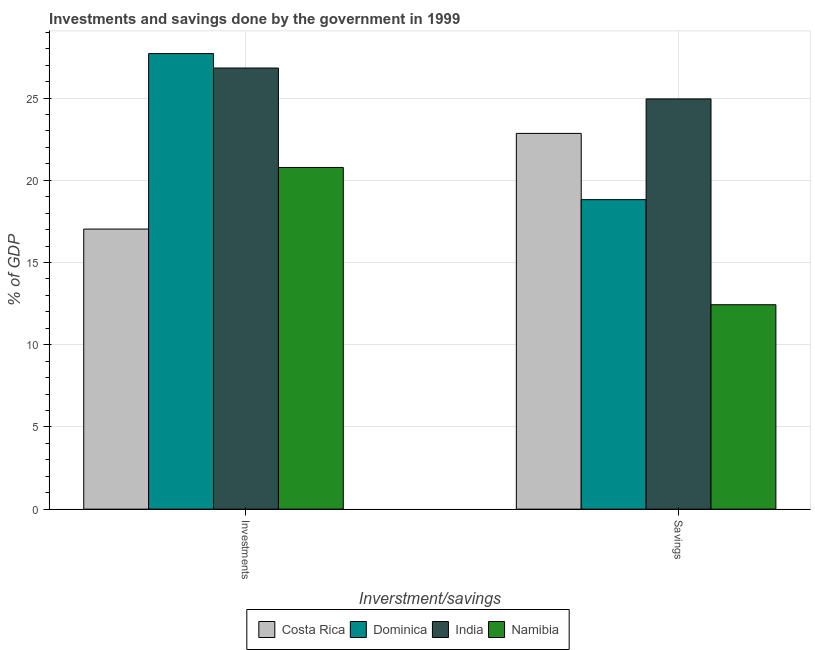How many groups of bars are there?
Provide a succinct answer. 2. Are the number of bars on each tick of the X-axis equal?
Provide a short and direct response. Yes. How many bars are there on the 2nd tick from the left?
Offer a very short reply. 4. How many bars are there on the 2nd tick from the right?
Your answer should be compact. 4. What is the label of the 2nd group of bars from the left?
Offer a terse response. Savings. What is the savings of government in Dominica?
Your answer should be compact. 18.82. Across all countries, what is the maximum investments of government?
Make the answer very short. 27.7. Across all countries, what is the minimum investments of government?
Give a very brief answer. 17.03. In which country was the savings of government maximum?
Give a very brief answer. India. What is the total investments of government in the graph?
Provide a succinct answer. 92.33. What is the difference between the savings of government in Dominica and that in Costa Rica?
Make the answer very short. -4.03. What is the difference between the savings of government in Costa Rica and the investments of government in India?
Your answer should be very brief. -3.97. What is the average investments of government per country?
Your answer should be compact. 23.08. What is the difference between the savings of government and investments of government in Costa Rica?
Ensure brevity in your answer.  5.82. What is the ratio of the investments of government in Namibia to that in Dominica?
Provide a succinct answer. 0.75. What does the 2nd bar from the left in Investments represents?
Your answer should be very brief. Dominica. What does the 4th bar from the right in Investments represents?
Your response must be concise. Costa Rica. How many countries are there in the graph?
Give a very brief answer. 4. What is the difference between two consecutive major ticks on the Y-axis?
Provide a succinct answer. 5. Does the graph contain any zero values?
Ensure brevity in your answer.  No. Does the graph contain grids?
Offer a very short reply. Yes. Where does the legend appear in the graph?
Offer a terse response. Bottom center. How are the legend labels stacked?
Your answer should be very brief. Horizontal. What is the title of the graph?
Provide a succinct answer. Investments and savings done by the government in 1999. Does "Philippines" appear as one of the legend labels in the graph?
Offer a terse response. No. What is the label or title of the X-axis?
Provide a succinct answer. Inverstment/savings. What is the label or title of the Y-axis?
Offer a terse response. % of GDP. What is the % of GDP of Costa Rica in Investments?
Your response must be concise. 17.03. What is the % of GDP in Dominica in Investments?
Give a very brief answer. 27.7. What is the % of GDP in India in Investments?
Your response must be concise. 26.82. What is the % of GDP in Namibia in Investments?
Keep it short and to the point. 20.78. What is the % of GDP of Costa Rica in Savings?
Provide a short and direct response. 22.85. What is the % of GDP of Dominica in Savings?
Your answer should be very brief. 18.82. What is the % of GDP of India in Savings?
Make the answer very short. 24.95. What is the % of GDP in Namibia in Savings?
Your response must be concise. 12.43. Across all Inverstment/savings, what is the maximum % of GDP in Costa Rica?
Your answer should be very brief. 22.85. Across all Inverstment/savings, what is the maximum % of GDP in Dominica?
Provide a succinct answer. 27.7. Across all Inverstment/savings, what is the maximum % of GDP of India?
Provide a succinct answer. 26.82. Across all Inverstment/savings, what is the maximum % of GDP of Namibia?
Make the answer very short. 20.78. Across all Inverstment/savings, what is the minimum % of GDP of Costa Rica?
Provide a short and direct response. 17.03. Across all Inverstment/savings, what is the minimum % of GDP in Dominica?
Offer a very short reply. 18.82. Across all Inverstment/savings, what is the minimum % of GDP in India?
Your answer should be very brief. 24.95. Across all Inverstment/savings, what is the minimum % of GDP of Namibia?
Make the answer very short. 12.43. What is the total % of GDP of Costa Rica in the graph?
Keep it short and to the point. 39.88. What is the total % of GDP of Dominica in the graph?
Offer a very short reply. 46.52. What is the total % of GDP of India in the graph?
Provide a short and direct response. 51.77. What is the total % of GDP of Namibia in the graph?
Give a very brief answer. 33.21. What is the difference between the % of GDP of Costa Rica in Investments and that in Savings?
Ensure brevity in your answer.  -5.82. What is the difference between the % of GDP in Dominica in Investments and that in Savings?
Your response must be concise. 8.88. What is the difference between the % of GDP in India in Investments and that in Savings?
Make the answer very short. 1.88. What is the difference between the % of GDP in Namibia in Investments and that in Savings?
Keep it short and to the point. 8.35. What is the difference between the % of GDP in Costa Rica in Investments and the % of GDP in Dominica in Savings?
Provide a succinct answer. -1.79. What is the difference between the % of GDP in Costa Rica in Investments and the % of GDP in India in Savings?
Offer a terse response. -7.91. What is the difference between the % of GDP of Costa Rica in Investments and the % of GDP of Namibia in Savings?
Offer a very short reply. 4.6. What is the difference between the % of GDP in Dominica in Investments and the % of GDP in India in Savings?
Make the answer very short. 2.76. What is the difference between the % of GDP of Dominica in Investments and the % of GDP of Namibia in Savings?
Offer a very short reply. 15.27. What is the difference between the % of GDP in India in Investments and the % of GDP in Namibia in Savings?
Provide a short and direct response. 14.39. What is the average % of GDP of Costa Rica per Inverstment/savings?
Make the answer very short. 19.94. What is the average % of GDP of Dominica per Inverstment/savings?
Offer a very short reply. 23.26. What is the average % of GDP of India per Inverstment/savings?
Give a very brief answer. 25.88. What is the average % of GDP of Namibia per Inverstment/savings?
Ensure brevity in your answer.  16.6. What is the difference between the % of GDP of Costa Rica and % of GDP of Dominica in Investments?
Offer a very short reply. -10.67. What is the difference between the % of GDP in Costa Rica and % of GDP in India in Investments?
Your answer should be compact. -9.79. What is the difference between the % of GDP in Costa Rica and % of GDP in Namibia in Investments?
Ensure brevity in your answer.  -3.75. What is the difference between the % of GDP in Dominica and % of GDP in India in Investments?
Ensure brevity in your answer.  0.88. What is the difference between the % of GDP in Dominica and % of GDP in Namibia in Investments?
Make the answer very short. 6.92. What is the difference between the % of GDP of India and % of GDP of Namibia in Investments?
Make the answer very short. 6.05. What is the difference between the % of GDP in Costa Rica and % of GDP in Dominica in Savings?
Offer a terse response. 4.03. What is the difference between the % of GDP of Costa Rica and % of GDP of India in Savings?
Make the answer very short. -2.1. What is the difference between the % of GDP of Costa Rica and % of GDP of Namibia in Savings?
Ensure brevity in your answer.  10.42. What is the difference between the % of GDP in Dominica and % of GDP in India in Savings?
Make the answer very short. -6.13. What is the difference between the % of GDP of Dominica and % of GDP of Namibia in Savings?
Offer a very short reply. 6.39. What is the difference between the % of GDP in India and % of GDP in Namibia in Savings?
Make the answer very short. 12.51. What is the ratio of the % of GDP of Costa Rica in Investments to that in Savings?
Offer a terse response. 0.75. What is the ratio of the % of GDP of Dominica in Investments to that in Savings?
Your response must be concise. 1.47. What is the ratio of the % of GDP of India in Investments to that in Savings?
Keep it short and to the point. 1.08. What is the ratio of the % of GDP of Namibia in Investments to that in Savings?
Offer a very short reply. 1.67. What is the difference between the highest and the second highest % of GDP of Costa Rica?
Your answer should be very brief. 5.82. What is the difference between the highest and the second highest % of GDP of Dominica?
Give a very brief answer. 8.88. What is the difference between the highest and the second highest % of GDP of India?
Offer a very short reply. 1.88. What is the difference between the highest and the second highest % of GDP in Namibia?
Your response must be concise. 8.35. What is the difference between the highest and the lowest % of GDP in Costa Rica?
Your answer should be compact. 5.82. What is the difference between the highest and the lowest % of GDP of Dominica?
Offer a very short reply. 8.88. What is the difference between the highest and the lowest % of GDP in India?
Provide a short and direct response. 1.88. What is the difference between the highest and the lowest % of GDP of Namibia?
Your response must be concise. 8.35. 